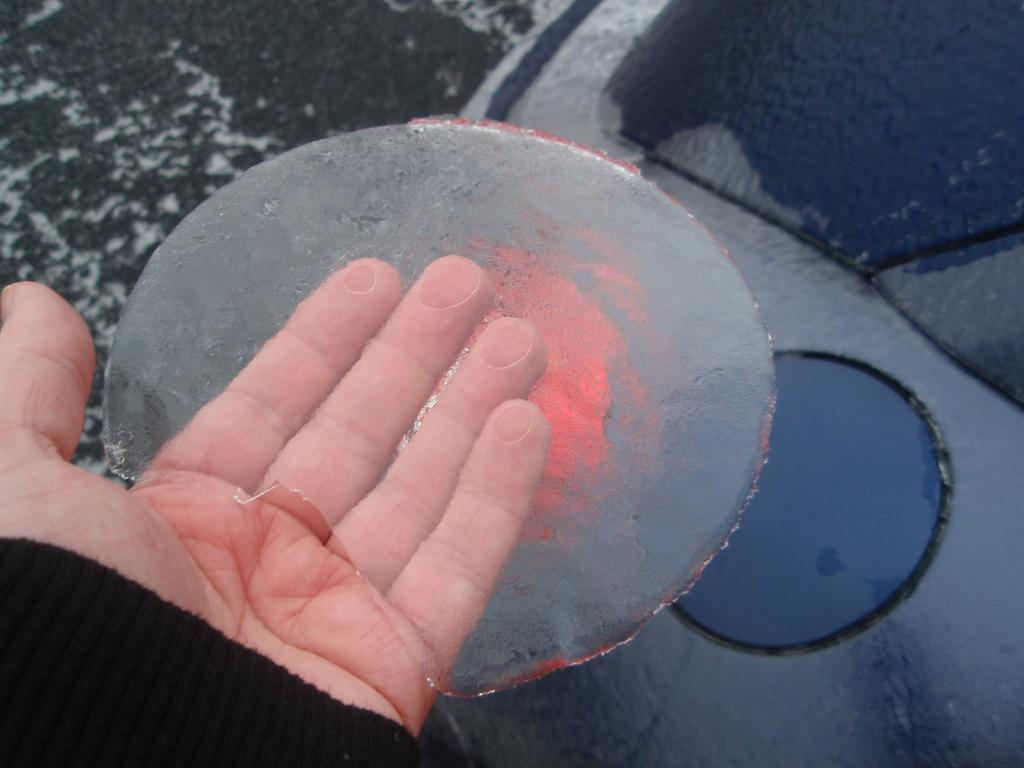Where was the image taken? The image was taken outdoors. What can be seen on the left side of the image? There is a hand of a person holding ice on the left side of the image. What is visible in the background of the image? In the background, there appears to be a vehicle covered with snow. How many books can be seen on the person's hand in the image? There are no books visible in the image; the person's hand is holding ice. Can you spot a bee buzzing around the vehicle in the background? There is no bee present in the image; the vehicle is covered with snow. 